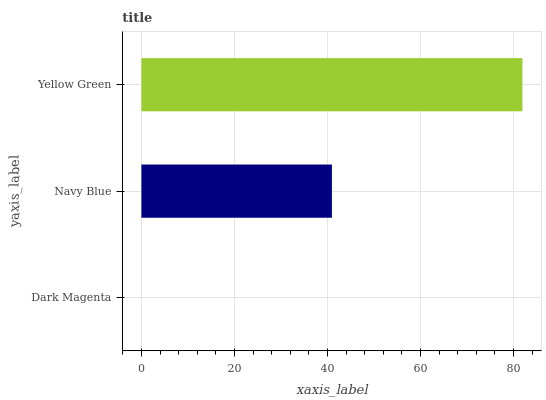Is Dark Magenta the minimum?
Answer yes or no. Yes. Is Yellow Green the maximum?
Answer yes or no. Yes. Is Navy Blue the minimum?
Answer yes or no. No. Is Navy Blue the maximum?
Answer yes or no. No. Is Navy Blue greater than Dark Magenta?
Answer yes or no. Yes. Is Dark Magenta less than Navy Blue?
Answer yes or no. Yes. Is Dark Magenta greater than Navy Blue?
Answer yes or no. No. Is Navy Blue less than Dark Magenta?
Answer yes or no. No. Is Navy Blue the high median?
Answer yes or no. Yes. Is Navy Blue the low median?
Answer yes or no. Yes. Is Yellow Green the high median?
Answer yes or no. No. Is Yellow Green the low median?
Answer yes or no. No. 